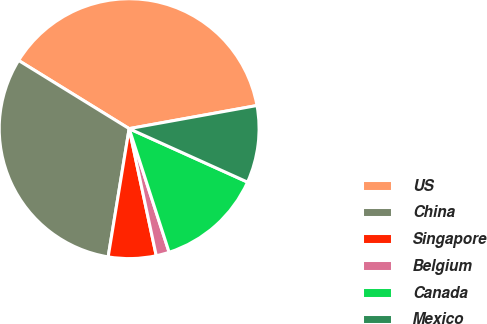<chart> <loc_0><loc_0><loc_500><loc_500><pie_chart><fcel>US<fcel>China<fcel>Singapore<fcel>Belgium<fcel>Canada<fcel>Mexico<nl><fcel>38.35%<fcel>31.21%<fcel>5.93%<fcel>1.63%<fcel>13.27%<fcel>9.6%<nl></chart> 